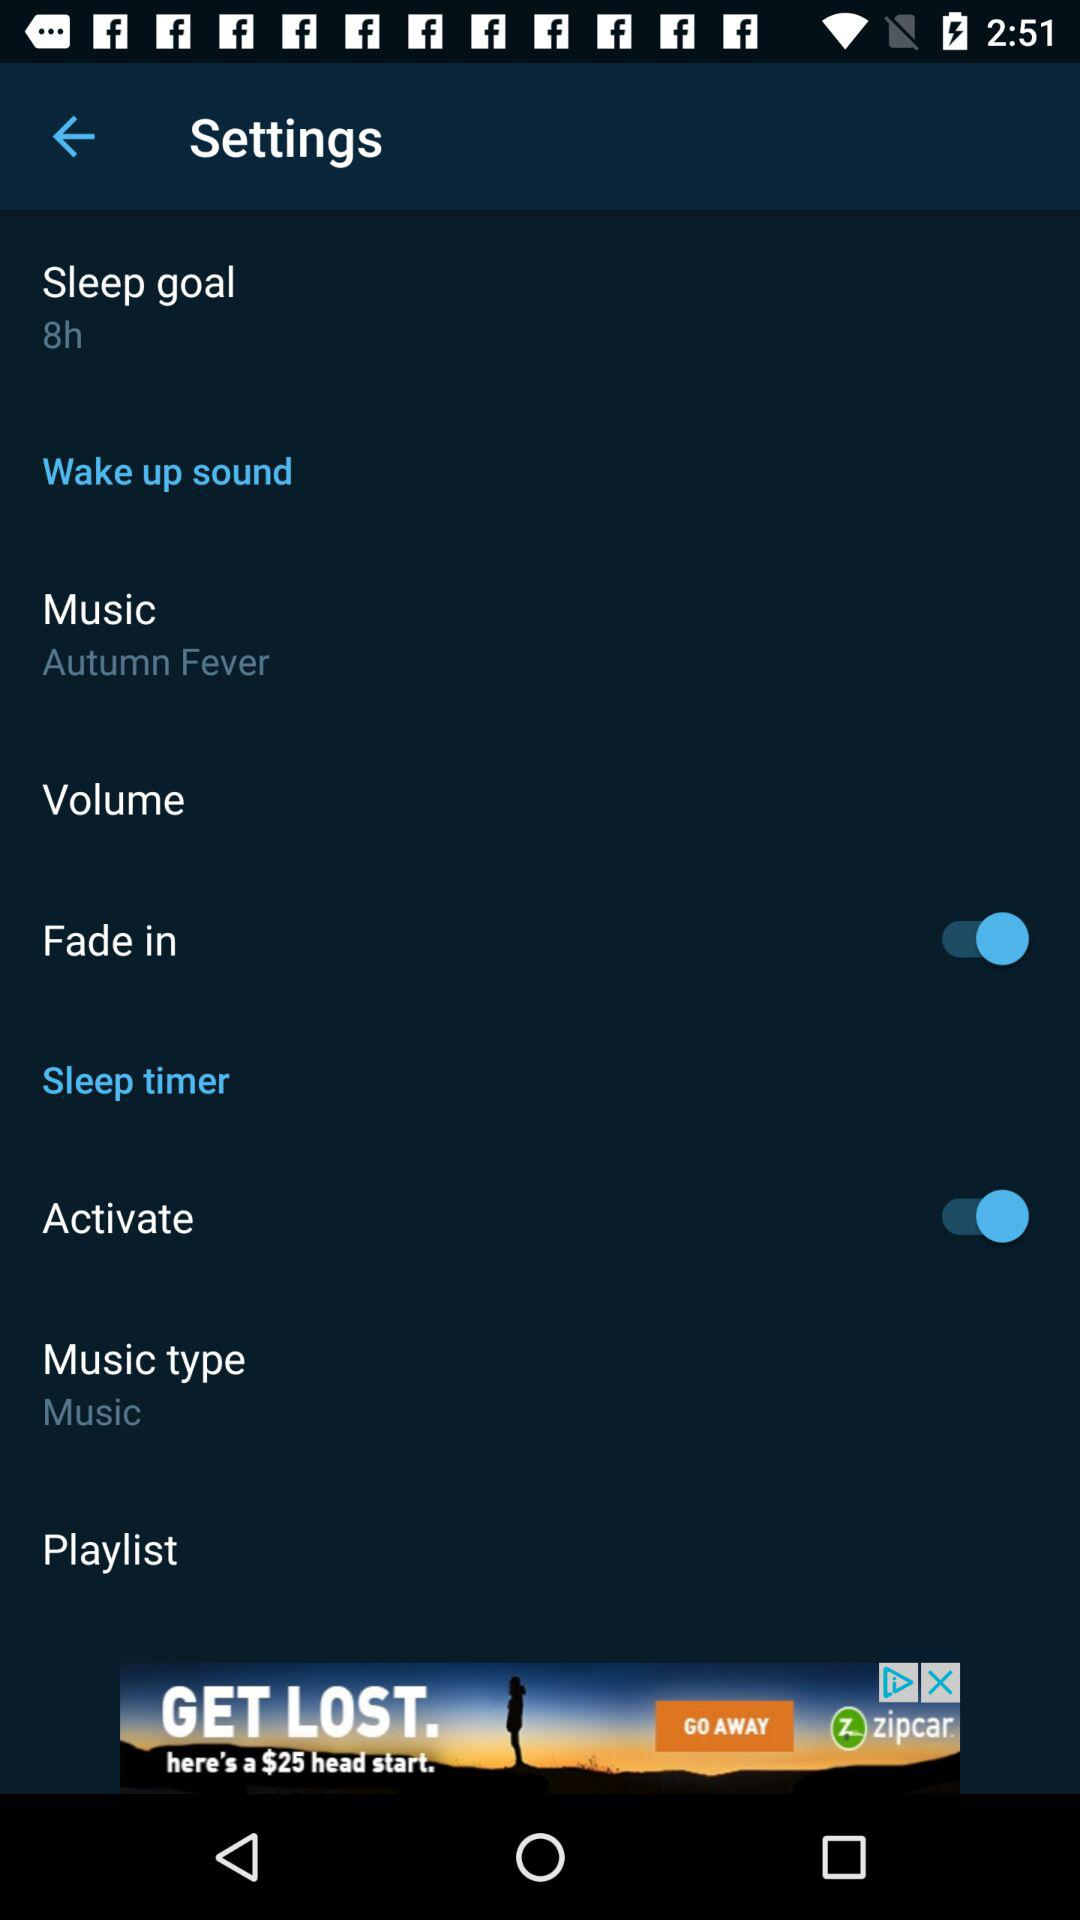What is the status of the "Activate"? The status is "on". 